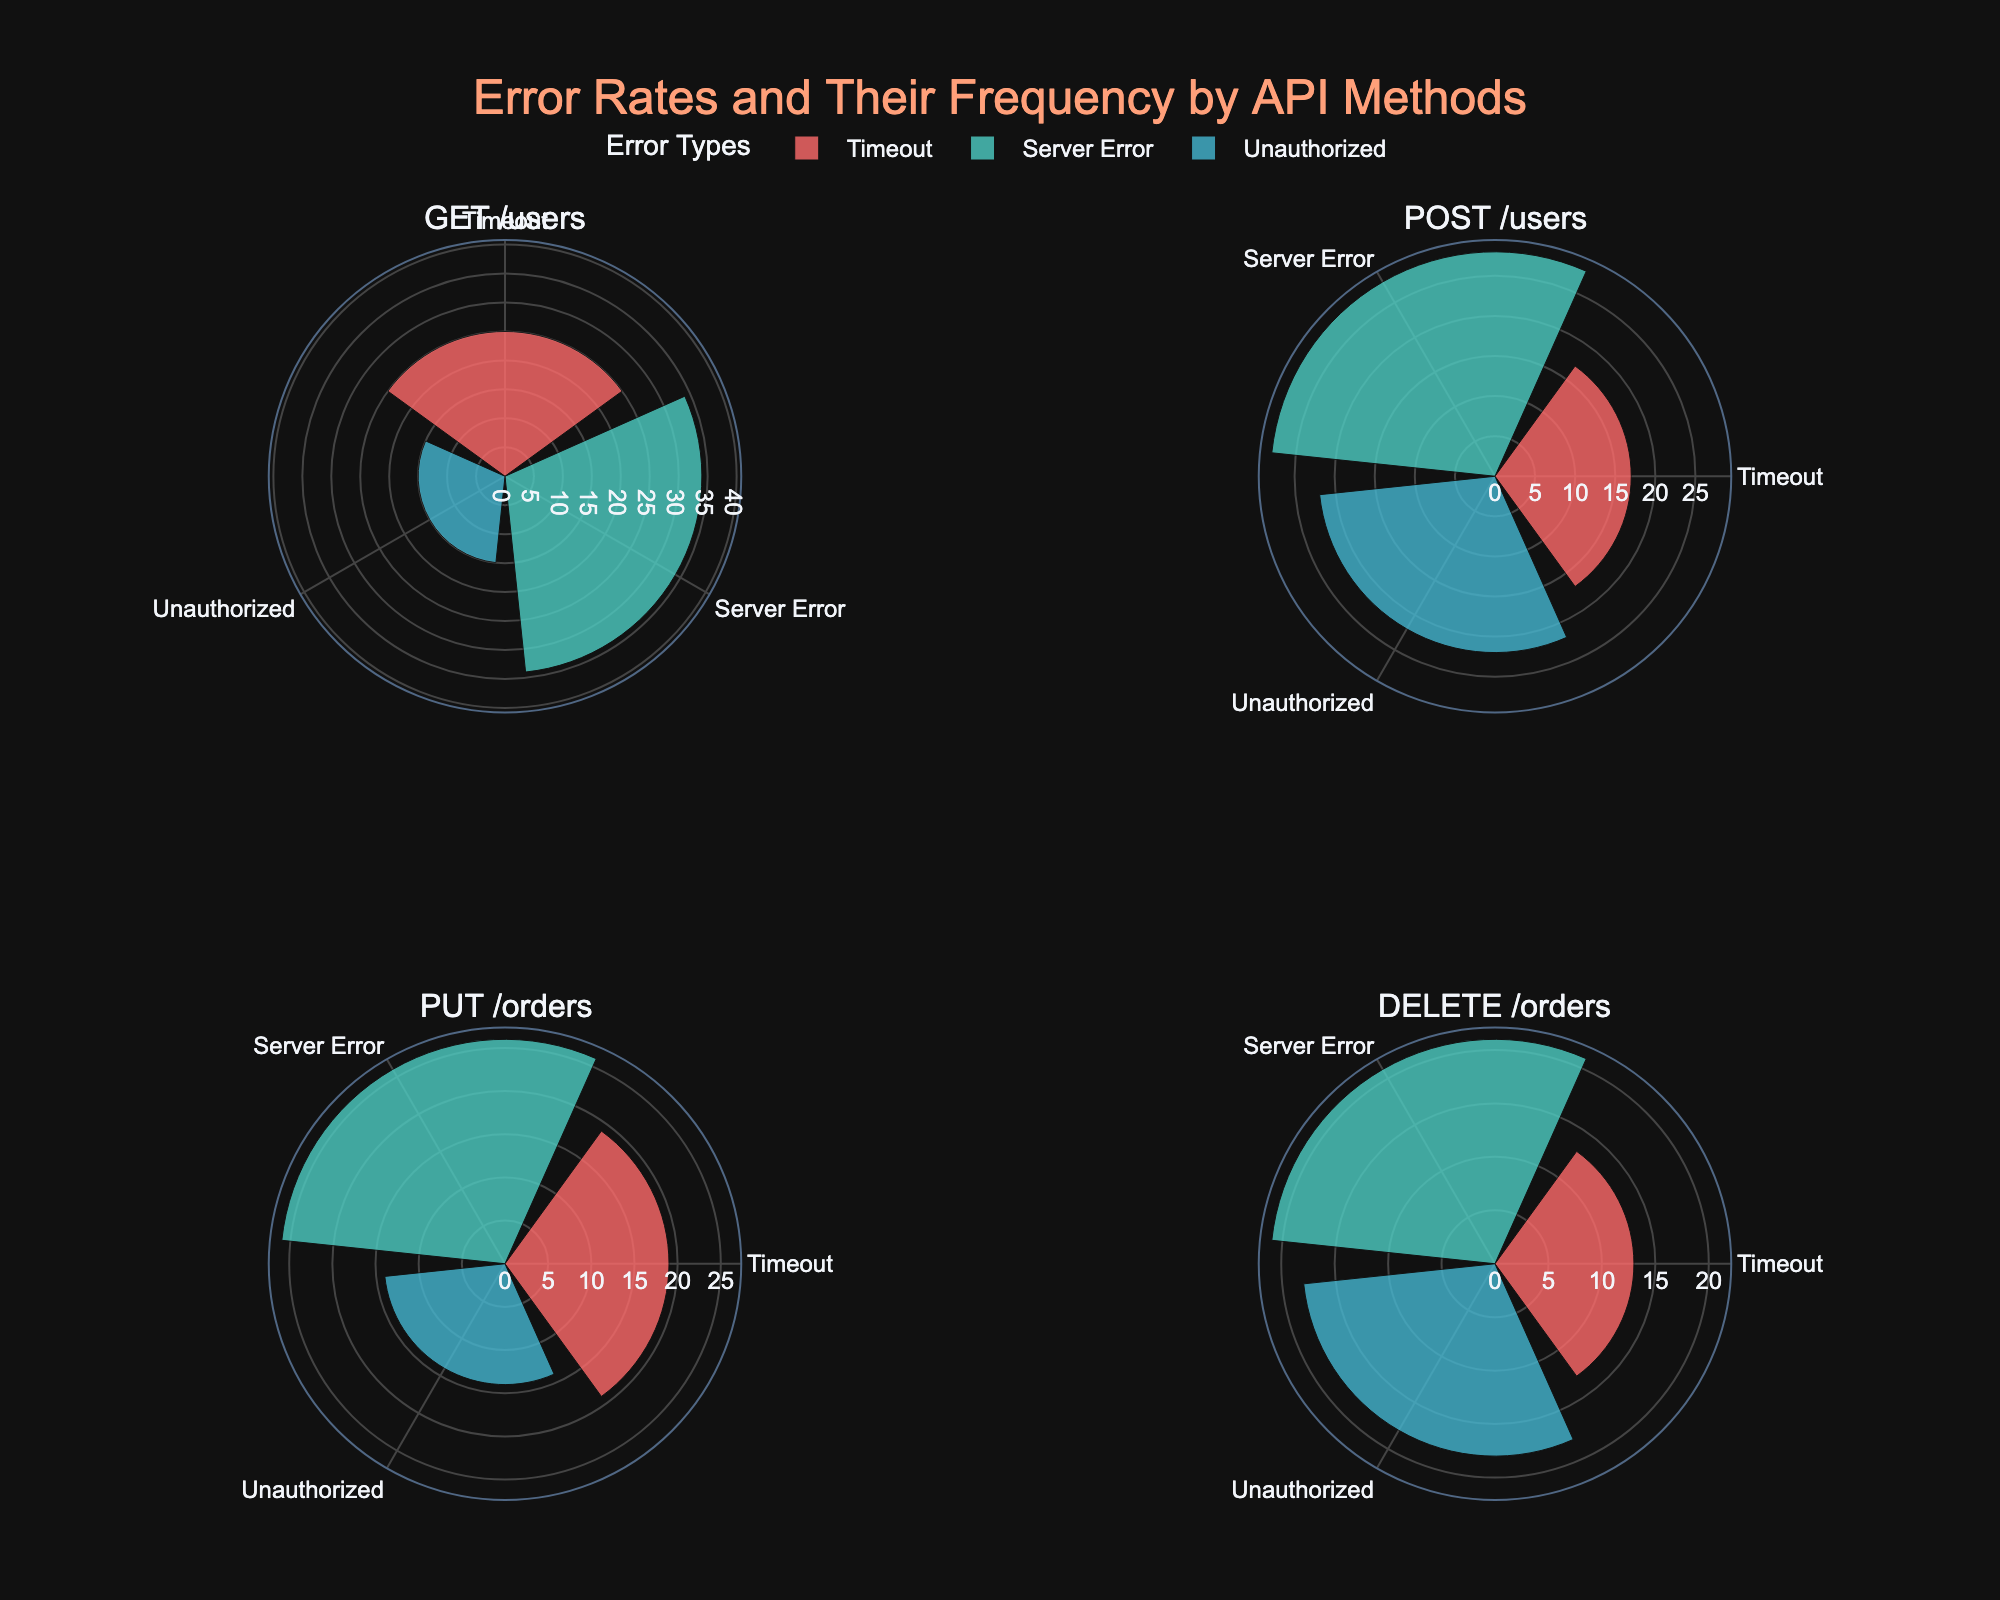What is the title of the figure? The title is provided at the top center of the figure.
Answer: Error Rates and Their Frequency by API Methods How many subplots are there in this figure? The layout of the figure shows four distinct subplots.
Answer: 4 Which API method has the highest frequency of Server Errors? By examining the various subplots and checking the heights of the 'Server Error' bars, we notice that 'GET /users' has the tallest bar.
Answer: GET /users What is the total number of Timeout errors across all API methods? Summing the frequencies of Timeout errors from all API methods: 25 (GET /users) + 17 (POST /users) + 19 (PUT /orders) + 13 (DELETE /orders) = 74
Answer: 74 Which API method has the least frequency of Unauthorized errors? By comparing the heights of the 'Unauthorized' bars, 'PUT /orders' has the smallest bar.
Answer: PUT /orders Is the frequency of Server Errors greater for POST /users or DELETE /orders? According to the heights of 'Server Error' bars in the corresponding subplots, 'POST /users' has a higher frequency (28) compared to 'DELETE /orders' (21).
Answer: POST /users Which error type appears most frequently in the PUT /orders method? By looking at the polar plot for 'PUT /orders', the 'Server Error' bar is the tallest.
Answer: Server Error How does the frequency of Unauthorized errors for GET /users compare to that for POST /users? In the subplots, the 'Unauthorized' bar for 'GET /users' is at 15, while for 'POST /users' it is at 22, indicating that POST /users has more such errors.
Answer: POST /users What's the sum of frequencies of all errors in DELETE /orders? Summing up the frequencies of all error types in the 'DELETE /orders' plot: Timeout (13) + Server Error (21) + Unauthorized (18) = 52.
Answer: 52 Which API method has the most balanced distribution of error types in terms of frequency? Reviewing the relative heights of bars in each subplot, 'PUT /orders' appears to have the least variance among the bars for Timeout (19), Server Error (26), and Unauthorized (14).
Answer: PUT /orders 